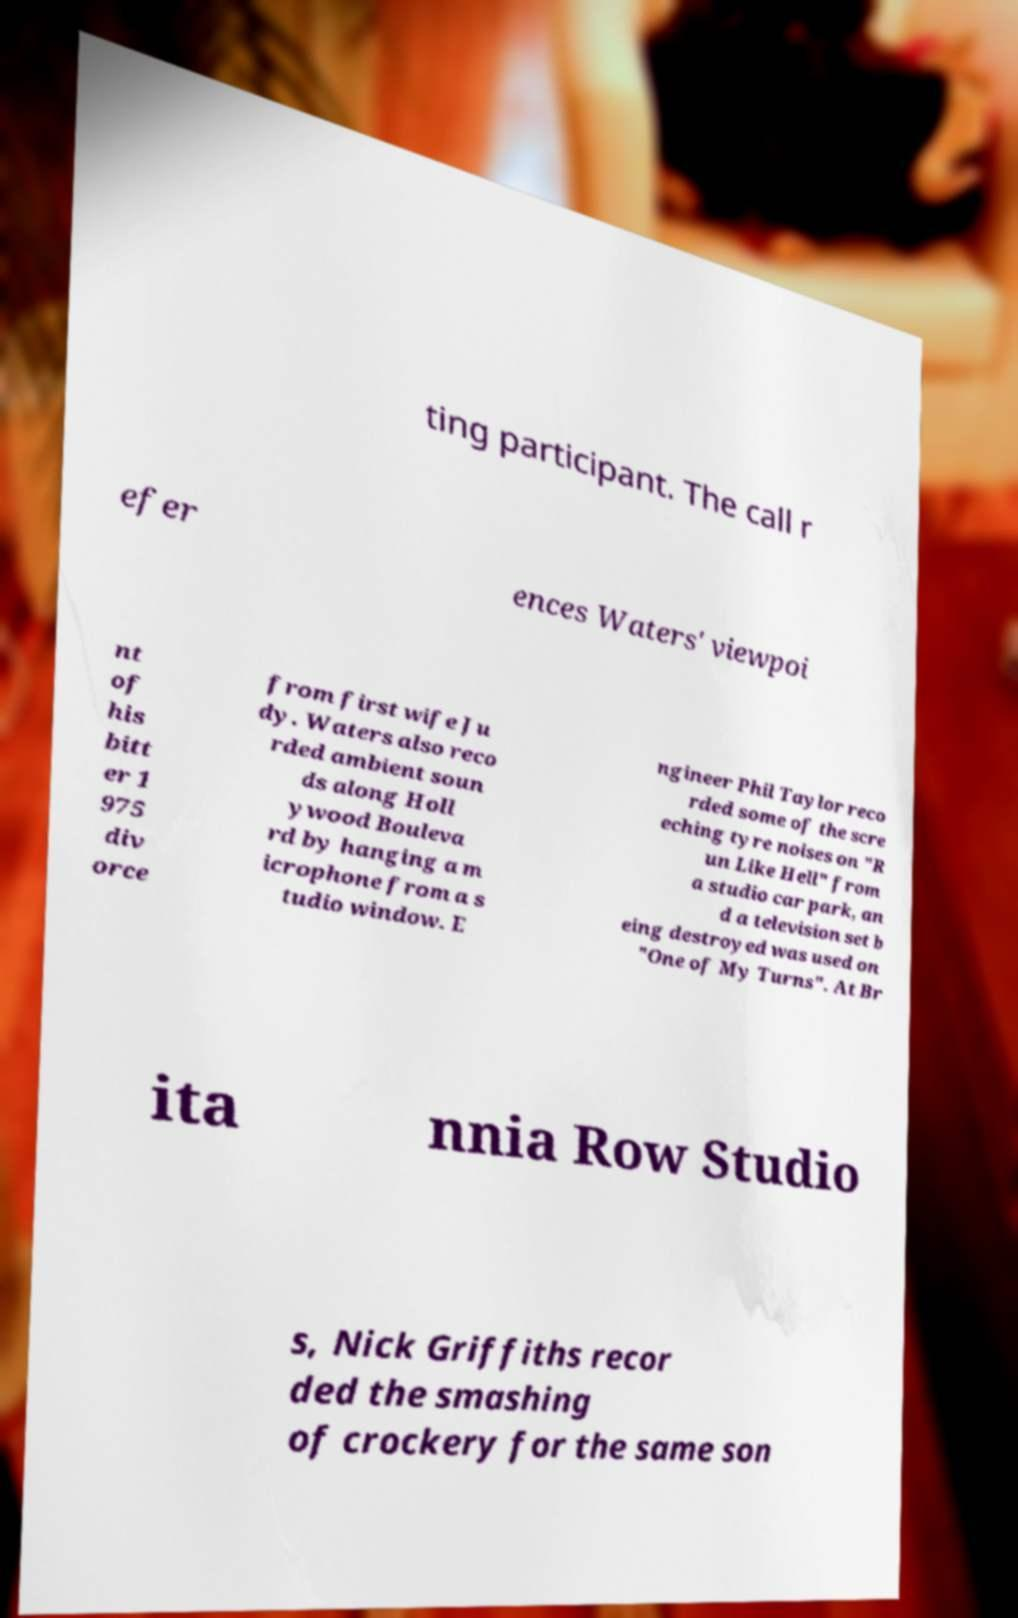Please identify and transcribe the text found in this image. ting participant. The call r efer ences Waters' viewpoi nt of his bitt er 1 975 div orce from first wife Ju dy. Waters also reco rded ambient soun ds along Holl ywood Bouleva rd by hanging a m icrophone from a s tudio window. E ngineer Phil Taylor reco rded some of the scre eching tyre noises on "R un Like Hell" from a studio car park, an d a television set b eing destroyed was used on "One of My Turns". At Br ita nnia Row Studio s, Nick Griffiths recor ded the smashing of crockery for the same son 